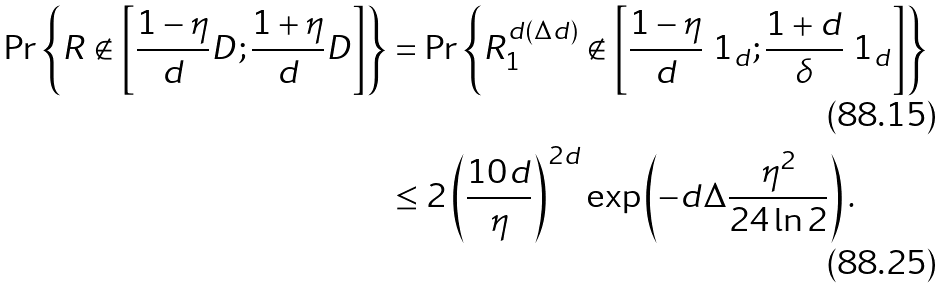Convert formula to latex. <formula><loc_0><loc_0><loc_500><loc_500>\Pr \left \{ R \not \in \left [ \frac { 1 - \eta } { d } D ; \frac { 1 + \eta } { d } D \right ] \right \} & = \Pr \left \{ R _ { 1 } ^ { d ( \Delta d ) } \not \in \left [ \frac { 1 - \eta } { d } \ 1 _ { d } ; \frac { 1 + d } { \delta } \ 1 _ { d } \right ] \right \} \\ & \leq 2 \left ( \frac { 1 0 d } { \eta } \right ) ^ { 2 d } \exp \left ( - d \Delta \frac { \eta ^ { 2 } } { 2 4 \ln 2 } \right ) .</formula> 